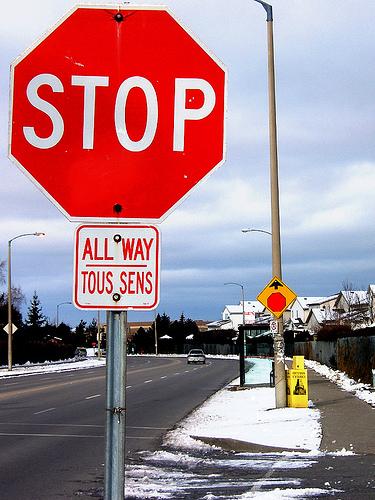What does it say under "All Way"?
Short answer required. Tous sens. Is this picture taken in America?
Answer briefly. Yes. Where is the stop sign?
Short answer required. In front. Is it cold here?
Answer briefly. Yes. What does the sign say?
Short answer required. Stop. 